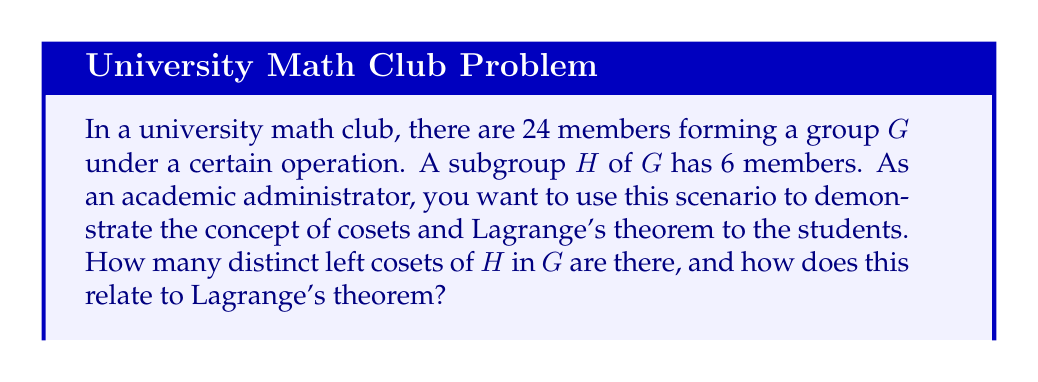Help me with this question. Let's approach this step-by-step:

1) First, recall the definition of a left coset. For a group G and a subgroup H, a left coset of H in G is a set of the form $aH = \{ah : h \in H\}$ for some $a \in G$.

2) Lagrange's theorem states that for a finite group G and a subgroup H of G, the order of H divides the order of G. Mathematically, $|G| = |H| \cdot [G:H]$, where $[G:H]$ is the index of H in G, which is equal to the number of distinct left cosets of H in G.

3) In this case, we have:
   $|G| = 24$ (the order of the full group)
   $|H| = 6$ (the order of the subgroup)

4) To find the number of distinct left cosets, we can use the equation from Lagrange's theorem:
   
   $[G:H] = \frac{|G|}{|H|} = \frac{24}{6} = 4$

5) This means there are 4 distinct left cosets of H in G.

6) We can verify this result:
   - Each coset has the same number of elements as H, which is 6.
   - There are 4 cosets, each with 6 elements.
   - $4 \cdot 6 = 24$, which is indeed the total number of elements in G.

7) This example demonstrates Lagrange's theorem in action:
   - The order of H (6) divides the order of G (24).
   - The number of cosets (4) multiplied by the order of H (6) equals the order of G (24).

This scenario helps students understand the relationship between a group, its subgroups, and cosets, while also illustrating the practical application of Lagrange's theorem.
Answer: There are 4 distinct left cosets of H in G. This number is obtained by dividing the order of G (24) by the order of H (6), which aligns with Lagrange's theorem: $[G:H] = \frac{|G|}{|H|} = \frac{24}{6} = 4$. 